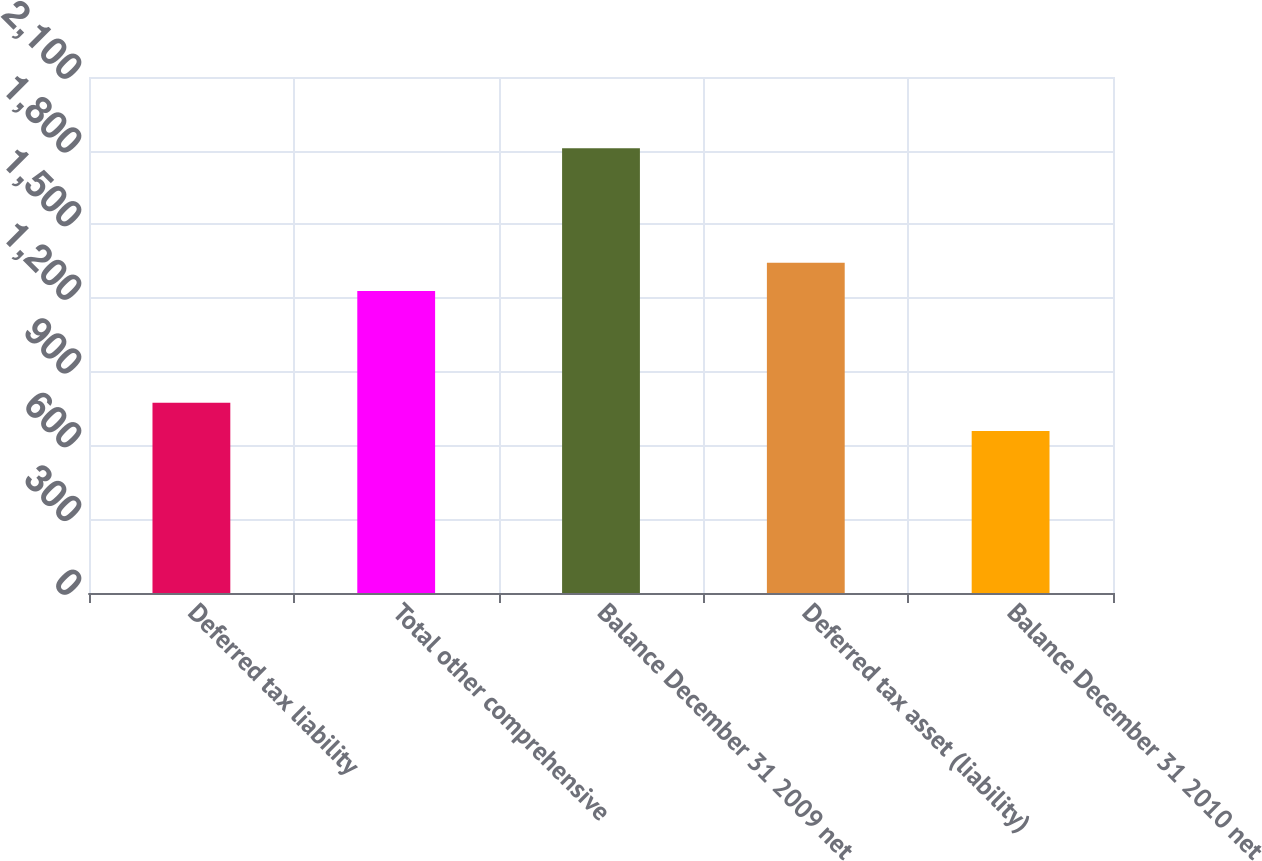<chart> <loc_0><loc_0><loc_500><loc_500><bar_chart><fcel>Deferred tax liability<fcel>Total other comprehensive<fcel>Balance December 31 2009 net<fcel>Deferred tax asset (liability)<fcel>Balance December 31 2010 net<nl><fcel>774.1<fcel>1229<fcel>1810<fcel>1344.1<fcel>659<nl></chart> 